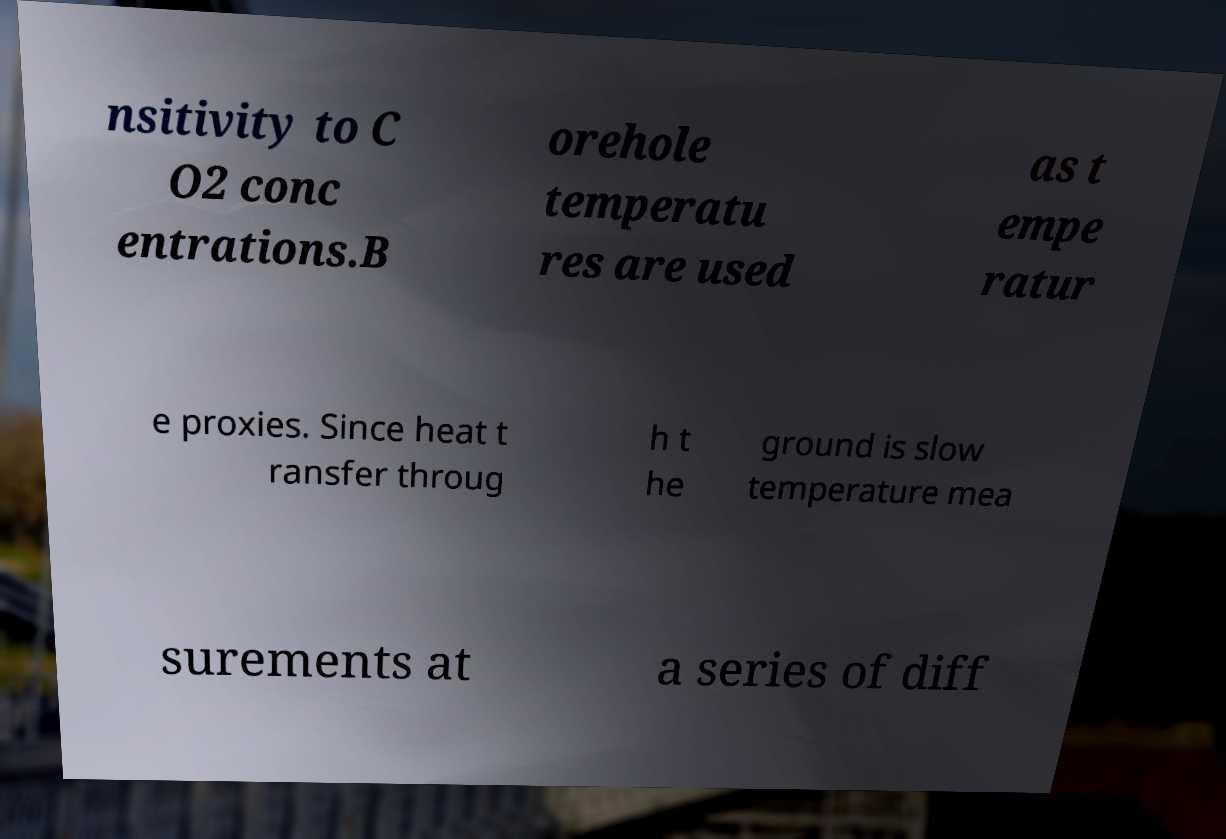Could you extract and type out the text from this image? nsitivity to C O2 conc entrations.B orehole temperatu res are used as t empe ratur e proxies. Since heat t ransfer throug h t he ground is slow temperature mea surements at a series of diff 